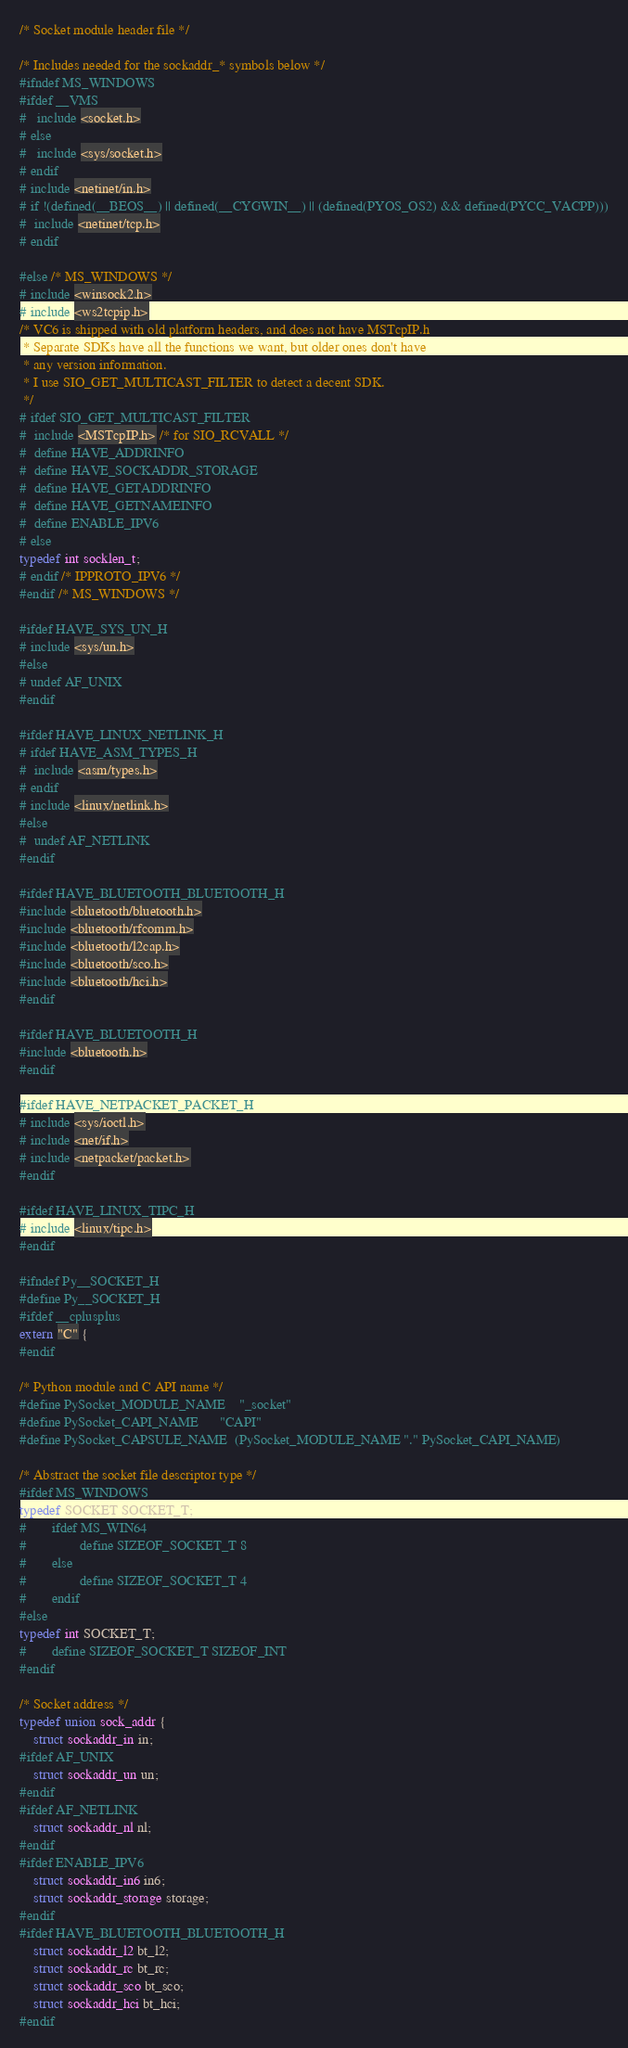<code> <loc_0><loc_0><loc_500><loc_500><_C_>/* Socket module header file */

/* Includes needed for the sockaddr_* symbols below */
#ifndef MS_WINDOWS
#ifdef __VMS
#   include <socket.h>
# else
#   include <sys/socket.h>
# endif
# include <netinet/in.h>
# if !(defined(__BEOS__) || defined(__CYGWIN__) || (defined(PYOS_OS2) && defined(PYCC_VACPP)))
#  include <netinet/tcp.h>
# endif

#else /* MS_WINDOWS */
# include <winsock2.h>
# include <ws2tcpip.h>
/* VC6 is shipped with old platform headers, and does not have MSTcpIP.h
 * Separate SDKs have all the functions we want, but older ones don't have
 * any version information.
 * I use SIO_GET_MULTICAST_FILTER to detect a decent SDK.
 */
# ifdef SIO_GET_MULTICAST_FILTER
#  include <MSTcpIP.h> /* for SIO_RCVALL */
#  define HAVE_ADDRINFO
#  define HAVE_SOCKADDR_STORAGE
#  define HAVE_GETADDRINFO
#  define HAVE_GETNAMEINFO
#  define ENABLE_IPV6
# else
typedef int socklen_t;
# endif /* IPPROTO_IPV6 */
#endif /* MS_WINDOWS */

#ifdef HAVE_SYS_UN_H
# include <sys/un.h>
#else
# undef AF_UNIX
#endif

#ifdef HAVE_LINUX_NETLINK_H
# ifdef HAVE_ASM_TYPES_H
#  include <asm/types.h>
# endif
# include <linux/netlink.h>
#else
#  undef AF_NETLINK
#endif

#ifdef HAVE_BLUETOOTH_BLUETOOTH_H
#include <bluetooth/bluetooth.h>
#include <bluetooth/rfcomm.h>
#include <bluetooth/l2cap.h>
#include <bluetooth/sco.h>
#include <bluetooth/hci.h>
#endif

#ifdef HAVE_BLUETOOTH_H
#include <bluetooth.h>
#endif

#ifdef HAVE_NETPACKET_PACKET_H
# include <sys/ioctl.h>
# include <net/if.h>
# include <netpacket/packet.h>
#endif

#ifdef HAVE_LINUX_TIPC_H
# include <linux/tipc.h>
#endif

#ifndef Py__SOCKET_H
#define Py__SOCKET_H
#ifdef __cplusplus
extern "C" {
#endif

/* Python module and C API name */
#define PySocket_MODULE_NAME    "_socket"
#define PySocket_CAPI_NAME      "CAPI"
#define PySocket_CAPSULE_NAME  (PySocket_MODULE_NAME "." PySocket_CAPI_NAME)

/* Abstract the socket file descriptor type */
#ifdef MS_WINDOWS
typedef SOCKET SOCKET_T;
#       ifdef MS_WIN64
#               define SIZEOF_SOCKET_T 8
#       else
#               define SIZEOF_SOCKET_T 4
#       endif
#else
typedef int SOCKET_T;
#       define SIZEOF_SOCKET_T SIZEOF_INT
#endif

/* Socket address */
typedef union sock_addr {
    struct sockaddr_in in;
#ifdef AF_UNIX
    struct sockaddr_un un;
#endif
#ifdef AF_NETLINK
    struct sockaddr_nl nl;
#endif
#ifdef ENABLE_IPV6
    struct sockaddr_in6 in6;
    struct sockaddr_storage storage;
#endif
#ifdef HAVE_BLUETOOTH_BLUETOOTH_H
    struct sockaddr_l2 bt_l2;
    struct sockaddr_rc bt_rc;
    struct sockaddr_sco bt_sco;
    struct sockaddr_hci bt_hci;
#endif</code> 